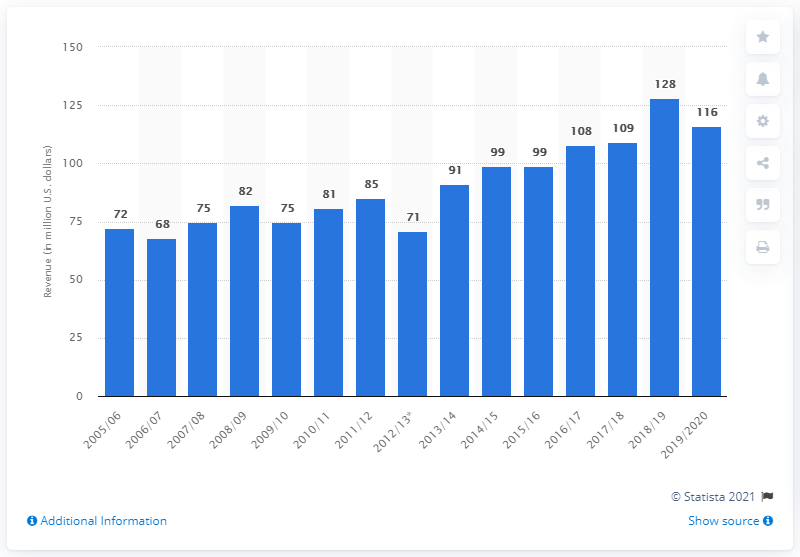Highlight a few significant elements in this photo. The revenue of the Carolina Hurricanes in the 2019/20 season was 116 million dollars. 